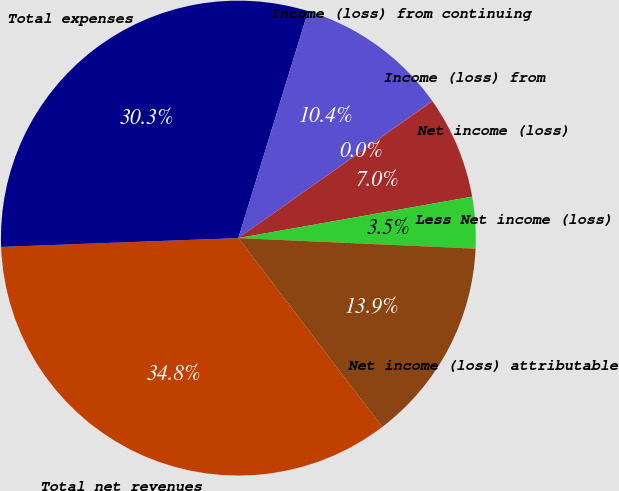<chart> <loc_0><loc_0><loc_500><loc_500><pie_chart><fcel>Total net revenues<fcel>Total expenses<fcel>Income (loss) from continuing<fcel>Income (loss) from<fcel>Net income (loss)<fcel>Less Net income (loss)<fcel>Net income (loss) attributable<nl><fcel>34.77%<fcel>30.34%<fcel>10.45%<fcel>0.03%<fcel>6.98%<fcel>3.5%<fcel>13.93%<nl></chart> 